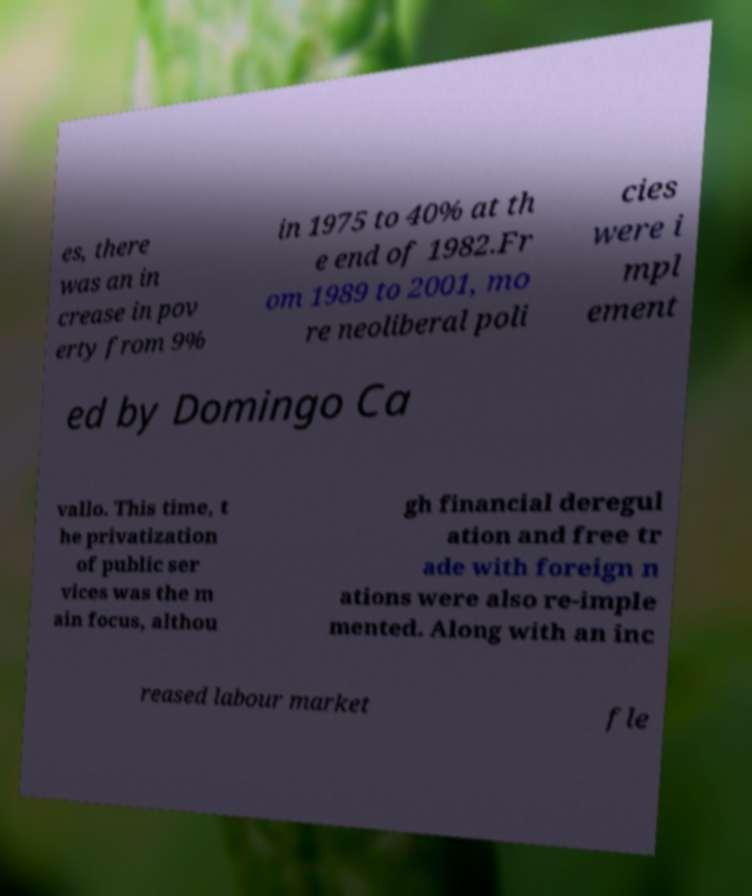Can you accurately transcribe the text from the provided image for me? es, there was an in crease in pov erty from 9% in 1975 to 40% at th e end of 1982.Fr om 1989 to 2001, mo re neoliberal poli cies were i mpl ement ed by Domingo Ca vallo. This time, t he privatization of public ser vices was the m ain focus, althou gh financial deregul ation and free tr ade with foreign n ations were also re-imple mented. Along with an inc reased labour market fle 